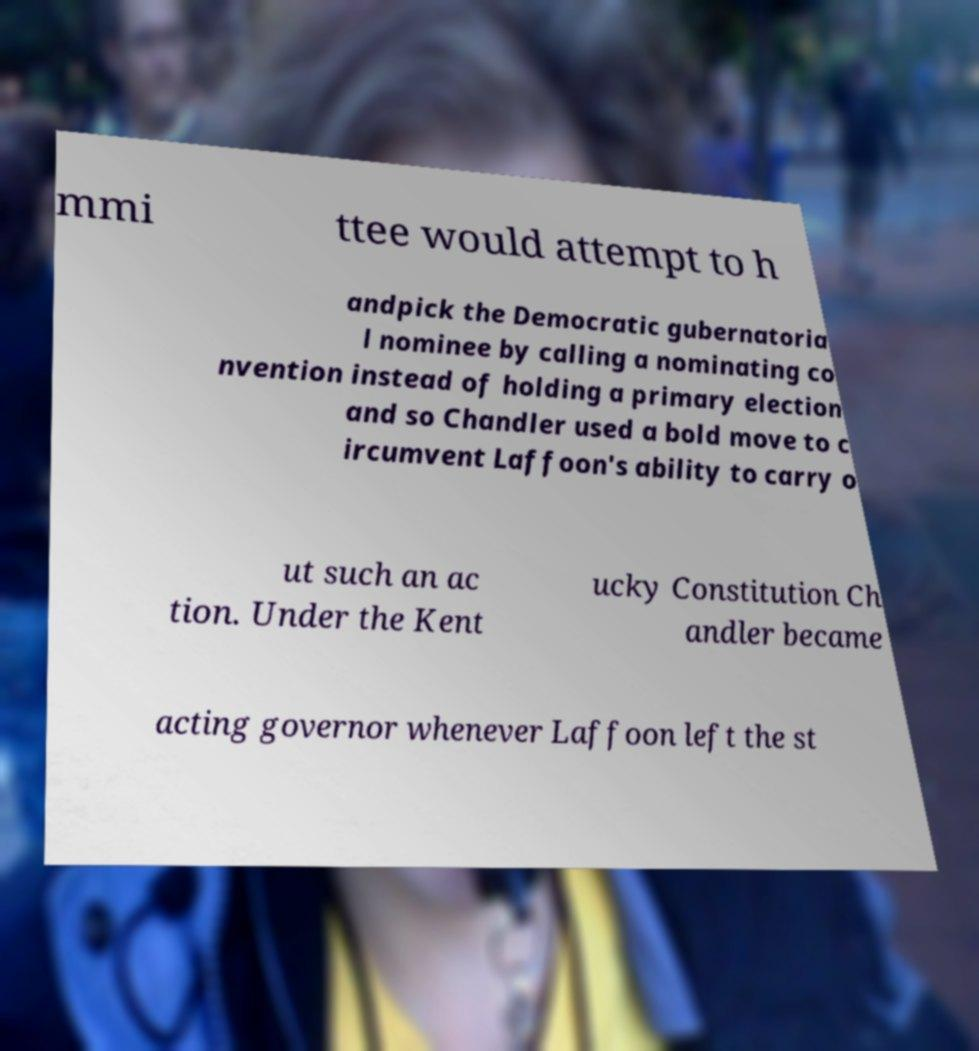Please read and relay the text visible in this image. What does it say? mmi ttee would attempt to h andpick the Democratic gubernatoria l nominee by calling a nominating co nvention instead of holding a primary election and so Chandler used a bold move to c ircumvent Laffoon's ability to carry o ut such an ac tion. Under the Kent ucky Constitution Ch andler became acting governor whenever Laffoon left the st 